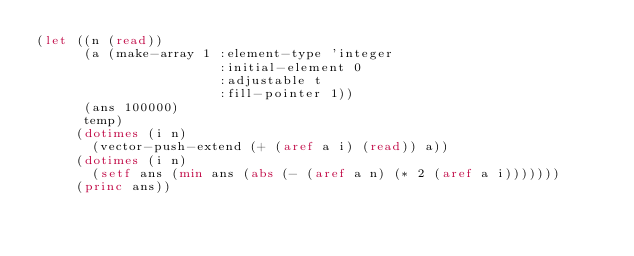<code> <loc_0><loc_0><loc_500><loc_500><_Lisp_>(let ((n (read))
      (a (make-array 1 :element-type 'integer
                       :initial-element 0
                       :adjustable t
                       :fill-pointer 1))
      (ans 100000)
      temp)
     (dotimes (i n)
       (vector-push-extend (+ (aref a i) (read)) a))
     (dotimes (i n)
       (setf ans (min ans (abs (- (aref a n) (* 2 (aref a i)))))))
     (princ ans))
</code> 